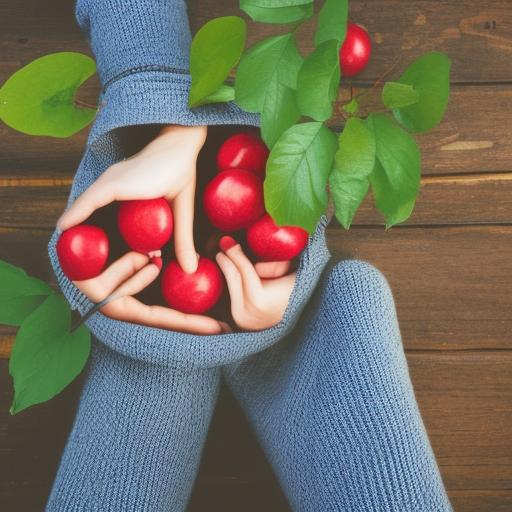What sort of emotions or concepts could this image represent on a symbolic level? Symbolically, the image of hands holding apples can represent generosity, fertility, and the giving nature of the Earth. It might also connote themes of sharing, caring for the environment, or even the concept of 'an apple a day' related to health and wellness. 